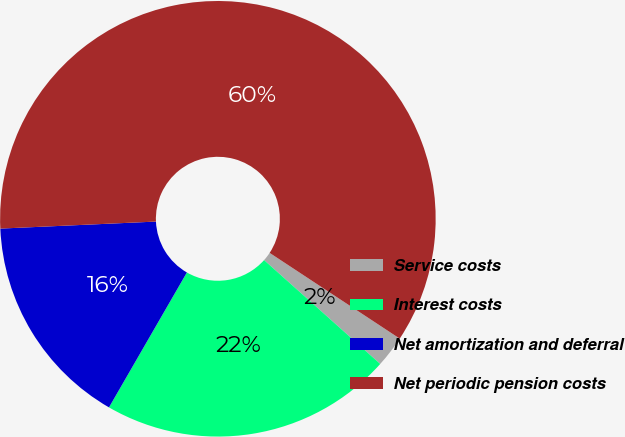<chart> <loc_0><loc_0><loc_500><loc_500><pie_chart><fcel>Service costs<fcel>Interest costs<fcel>Net amortization and deferral<fcel>Net periodic pension costs<nl><fcel>2.34%<fcel>21.72%<fcel>15.95%<fcel>59.99%<nl></chart> 